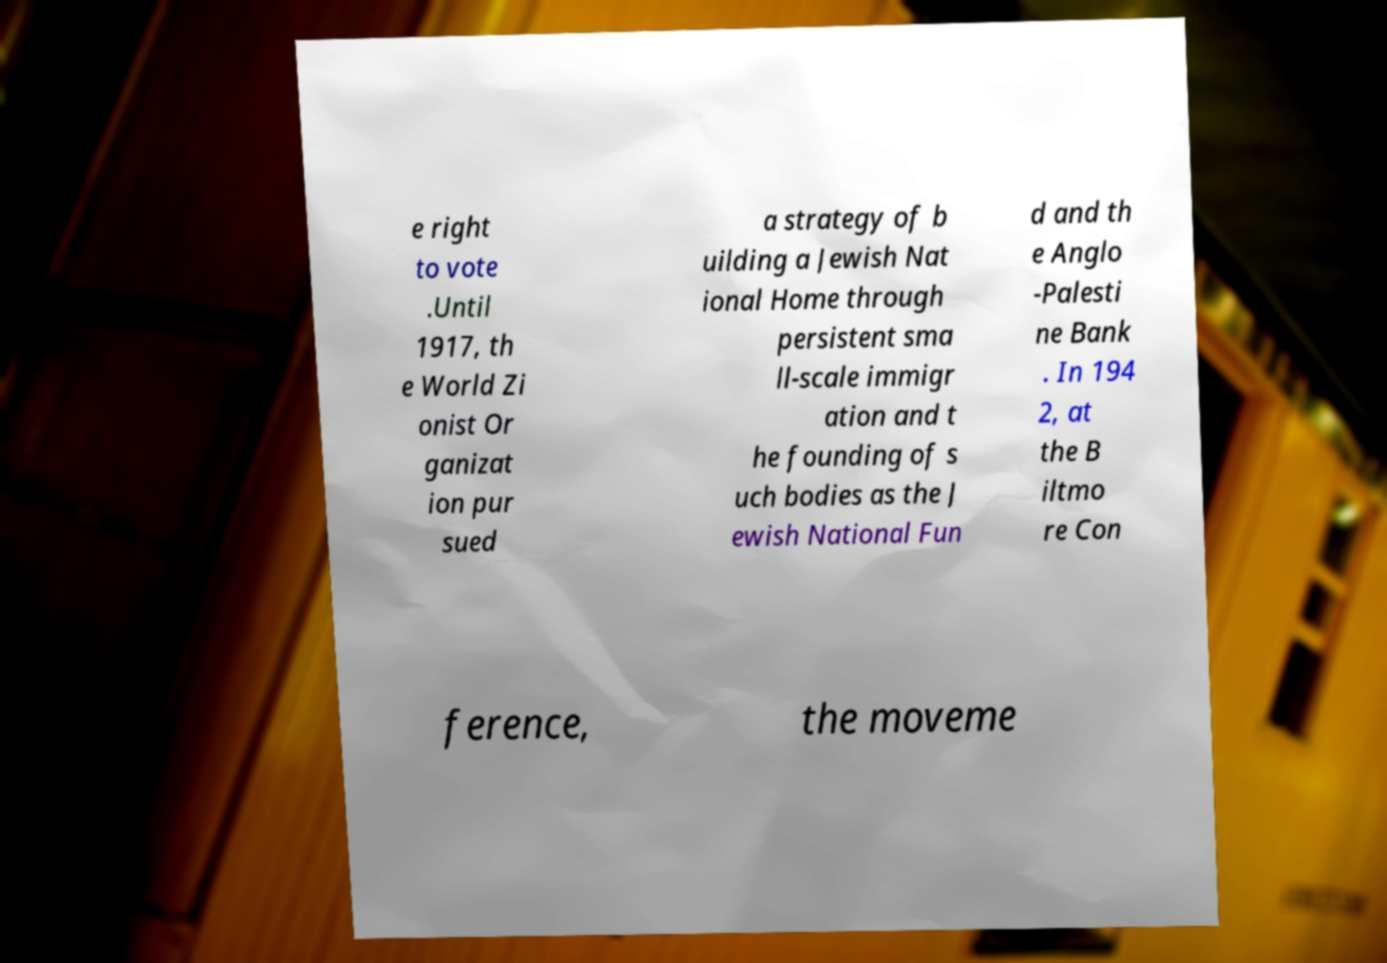For documentation purposes, I need the text within this image transcribed. Could you provide that? e right to vote .Until 1917, th e World Zi onist Or ganizat ion pur sued a strategy of b uilding a Jewish Nat ional Home through persistent sma ll-scale immigr ation and t he founding of s uch bodies as the J ewish National Fun d and th e Anglo -Palesti ne Bank . In 194 2, at the B iltmo re Con ference, the moveme 